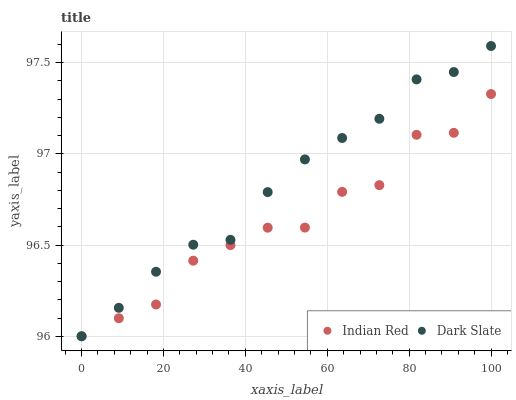Does Indian Red have the minimum area under the curve?
Answer yes or no. Yes. Does Dark Slate have the maximum area under the curve?
Answer yes or no. Yes. Does Indian Red have the maximum area under the curve?
Answer yes or no. No. Is Dark Slate the smoothest?
Answer yes or no. Yes. Is Indian Red the roughest?
Answer yes or no. Yes. Is Indian Red the smoothest?
Answer yes or no. No. Does Dark Slate have the lowest value?
Answer yes or no. Yes. Does Dark Slate have the highest value?
Answer yes or no. Yes. Does Indian Red have the highest value?
Answer yes or no. No. Does Dark Slate intersect Indian Red?
Answer yes or no. Yes. Is Dark Slate less than Indian Red?
Answer yes or no. No. Is Dark Slate greater than Indian Red?
Answer yes or no. No. 